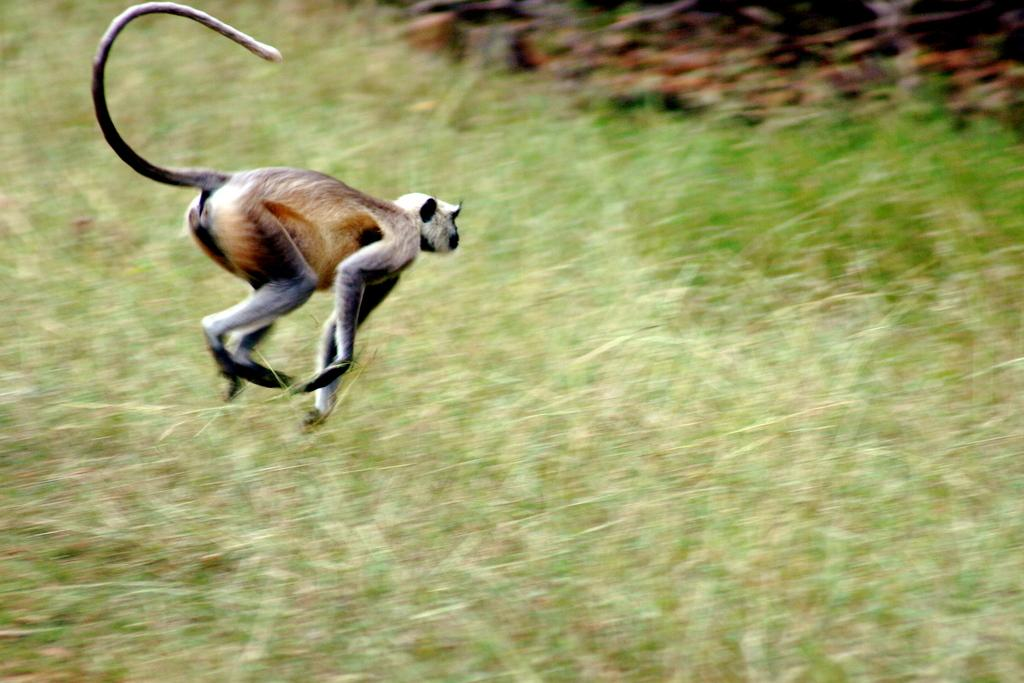What type of surface is visible on the ground in the image? There is grass on the ground in the image. What is the animal in the image doing? The animal is running in the image. Can you describe the background of the image? The background of the image is blurry. What type of cherry is being harvested in the image? There is no cherry or produce present in the image; it features grass and an animal running. 